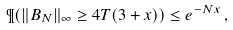<formula> <loc_0><loc_0><loc_500><loc_500>\P ( \| B _ { N } \| _ { \infty } \geq 4 T ( 3 + x ) ) \leq e ^ { - N x } \, ,</formula> 